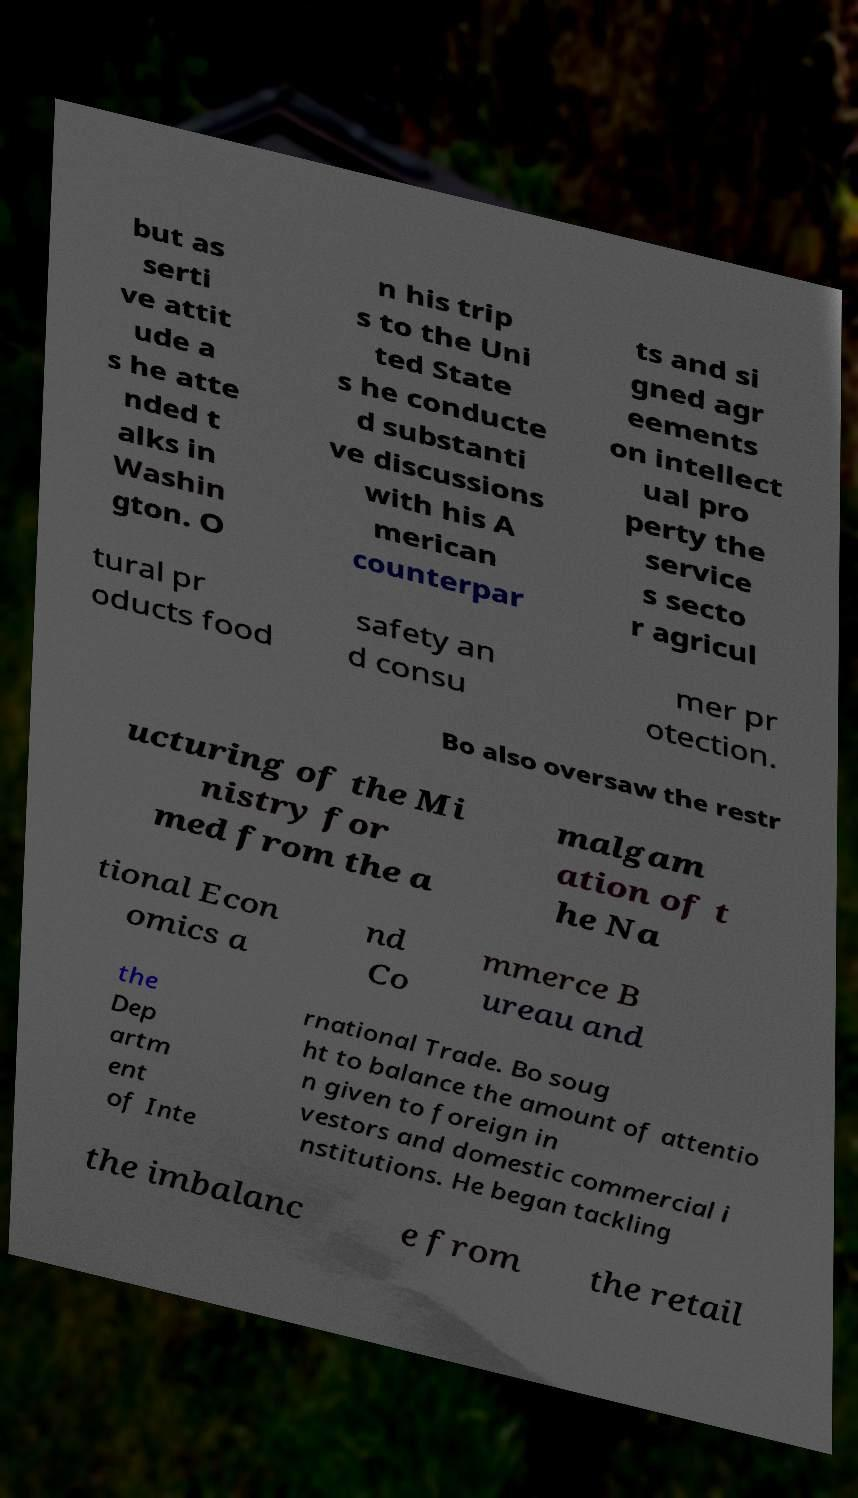There's text embedded in this image that I need extracted. Can you transcribe it verbatim? but as serti ve attit ude a s he atte nded t alks in Washin gton. O n his trip s to the Uni ted State s he conducte d substanti ve discussions with his A merican counterpar ts and si gned agr eements on intellect ual pro perty the service s secto r agricul tural pr oducts food safety an d consu mer pr otection. Bo also oversaw the restr ucturing of the Mi nistry for med from the a malgam ation of t he Na tional Econ omics a nd Co mmerce B ureau and the Dep artm ent of Inte rnational Trade. Bo soug ht to balance the amount of attentio n given to foreign in vestors and domestic commercial i nstitutions. He began tackling the imbalanc e from the retail 